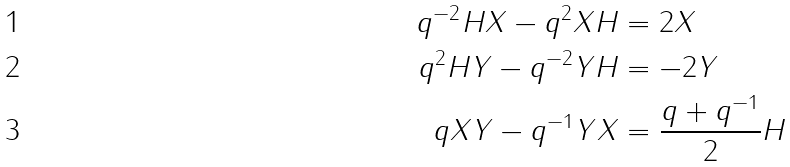<formula> <loc_0><loc_0><loc_500><loc_500>q ^ { - 2 } H X - q ^ { 2 } X H & = 2 X \\ q ^ { 2 } H Y - q ^ { - 2 } Y H & = - 2 Y \\ q X Y - q ^ { - 1 } Y X & = \frac { q + q ^ { - 1 } } { 2 } H</formula> 